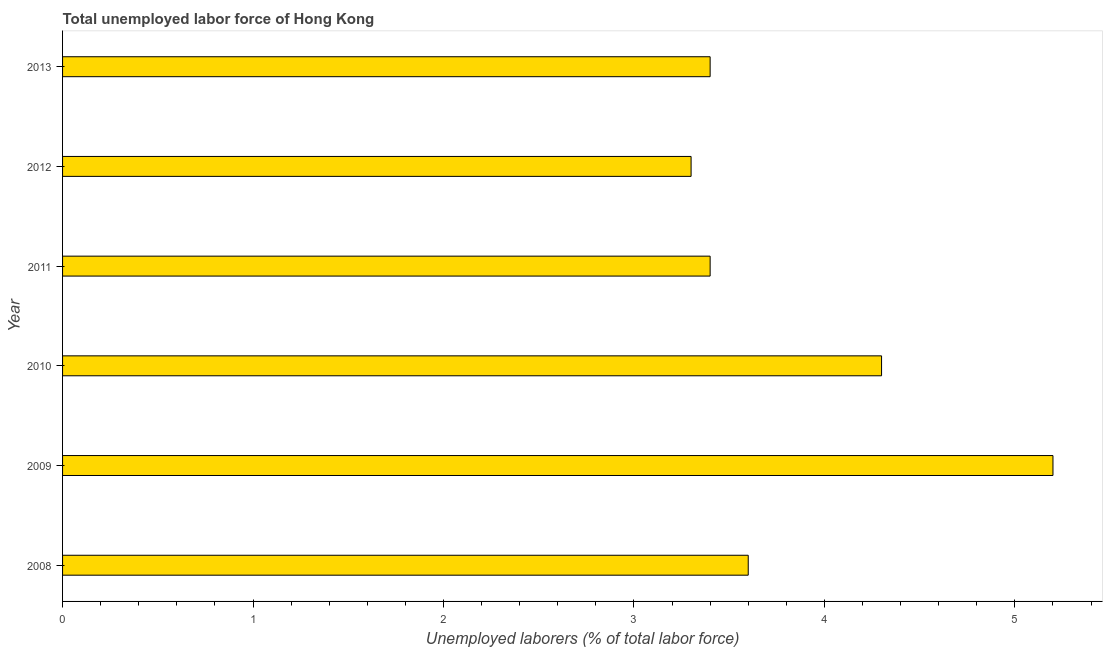What is the title of the graph?
Ensure brevity in your answer.  Total unemployed labor force of Hong Kong. What is the label or title of the X-axis?
Ensure brevity in your answer.  Unemployed laborers (% of total labor force). What is the total unemployed labour force in 2008?
Make the answer very short. 3.6. Across all years, what is the maximum total unemployed labour force?
Your response must be concise. 5.2. Across all years, what is the minimum total unemployed labour force?
Your answer should be compact. 3.3. What is the sum of the total unemployed labour force?
Your response must be concise. 23.2. What is the average total unemployed labour force per year?
Offer a terse response. 3.87. What is the median total unemployed labour force?
Make the answer very short. 3.5. What is the ratio of the total unemployed labour force in 2009 to that in 2013?
Provide a succinct answer. 1.53. Is the difference between the total unemployed labour force in 2008 and 2013 greater than the difference between any two years?
Provide a succinct answer. No. Is the sum of the total unemployed labour force in 2009 and 2013 greater than the maximum total unemployed labour force across all years?
Your response must be concise. Yes. Are all the bars in the graph horizontal?
Your answer should be compact. Yes. How many years are there in the graph?
Keep it short and to the point. 6. What is the difference between two consecutive major ticks on the X-axis?
Your answer should be compact. 1. Are the values on the major ticks of X-axis written in scientific E-notation?
Your answer should be very brief. No. What is the Unemployed laborers (% of total labor force) of 2008?
Your answer should be very brief. 3.6. What is the Unemployed laborers (% of total labor force) in 2009?
Provide a short and direct response. 5.2. What is the Unemployed laborers (% of total labor force) in 2010?
Keep it short and to the point. 4.3. What is the Unemployed laborers (% of total labor force) of 2011?
Your answer should be compact. 3.4. What is the Unemployed laborers (% of total labor force) in 2012?
Ensure brevity in your answer.  3.3. What is the Unemployed laborers (% of total labor force) in 2013?
Your response must be concise. 3.4. What is the difference between the Unemployed laborers (% of total labor force) in 2008 and 2009?
Your answer should be very brief. -1.6. What is the difference between the Unemployed laborers (% of total labor force) in 2008 and 2010?
Ensure brevity in your answer.  -0.7. What is the difference between the Unemployed laborers (% of total labor force) in 2008 and 2011?
Your answer should be very brief. 0.2. What is the difference between the Unemployed laborers (% of total labor force) in 2009 and 2010?
Give a very brief answer. 0.9. What is the difference between the Unemployed laborers (% of total labor force) in 2009 and 2011?
Your answer should be very brief. 1.8. What is the difference between the Unemployed laborers (% of total labor force) in 2009 and 2012?
Offer a terse response. 1.9. What is the difference between the Unemployed laborers (% of total labor force) in 2010 and 2012?
Your answer should be very brief. 1. What is the difference between the Unemployed laborers (% of total labor force) in 2010 and 2013?
Your answer should be compact. 0.9. What is the difference between the Unemployed laborers (% of total labor force) in 2011 and 2012?
Make the answer very short. 0.1. What is the difference between the Unemployed laborers (% of total labor force) in 2011 and 2013?
Provide a short and direct response. 0. What is the difference between the Unemployed laborers (% of total labor force) in 2012 and 2013?
Provide a succinct answer. -0.1. What is the ratio of the Unemployed laborers (% of total labor force) in 2008 to that in 2009?
Give a very brief answer. 0.69. What is the ratio of the Unemployed laborers (% of total labor force) in 2008 to that in 2010?
Offer a very short reply. 0.84. What is the ratio of the Unemployed laborers (% of total labor force) in 2008 to that in 2011?
Your response must be concise. 1.06. What is the ratio of the Unemployed laborers (% of total labor force) in 2008 to that in 2012?
Offer a very short reply. 1.09. What is the ratio of the Unemployed laborers (% of total labor force) in 2008 to that in 2013?
Give a very brief answer. 1.06. What is the ratio of the Unemployed laborers (% of total labor force) in 2009 to that in 2010?
Keep it short and to the point. 1.21. What is the ratio of the Unemployed laborers (% of total labor force) in 2009 to that in 2011?
Your answer should be compact. 1.53. What is the ratio of the Unemployed laborers (% of total labor force) in 2009 to that in 2012?
Offer a terse response. 1.58. What is the ratio of the Unemployed laborers (% of total labor force) in 2009 to that in 2013?
Your answer should be compact. 1.53. What is the ratio of the Unemployed laborers (% of total labor force) in 2010 to that in 2011?
Ensure brevity in your answer.  1.26. What is the ratio of the Unemployed laborers (% of total labor force) in 2010 to that in 2012?
Keep it short and to the point. 1.3. What is the ratio of the Unemployed laborers (% of total labor force) in 2010 to that in 2013?
Your answer should be very brief. 1.26. What is the ratio of the Unemployed laborers (% of total labor force) in 2012 to that in 2013?
Give a very brief answer. 0.97. 